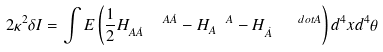<formula> <loc_0><loc_0><loc_500><loc_500>2 \kappa ^ { 2 } \delta I = \int E \left ( \frac { 1 } { 2 } H _ { A \dot { A } } ^ { \quad A \dot { A } } - H _ { A } ^ { \ \ A } - H _ { \dot { A } } ^ { \quad d o t A } \right ) d ^ { 4 } x d ^ { 4 } \theta</formula> 